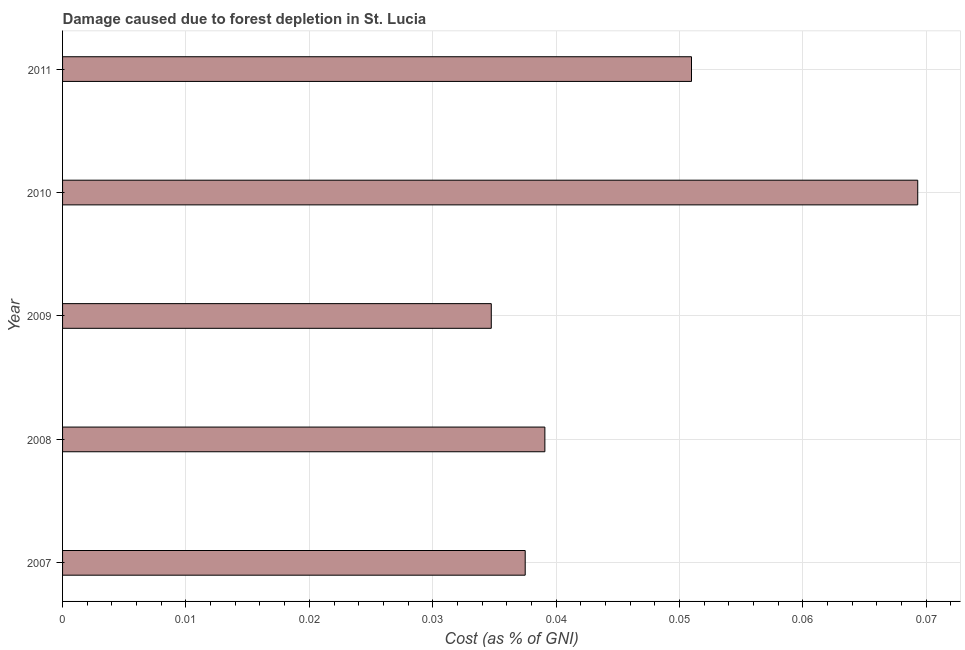What is the title of the graph?
Keep it short and to the point. Damage caused due to forest depletion in St. Lucia. What is the label or title of the X-axis?
Provide a short and direct response. Cost (as % of GNI). What is the label or title of the Y-axis?
Keep it short and to the point. Year. What is the damage caused due to forest depletion in 2007?
Your response must be concise. 0.04. Across all years, what is the maximum damage caused due to forest depletion?
Provide a short and direct response. 0.07. Across all years, what is the minimum damage caused due to forest depletion?
Make the answer very short. 0.03. In which year was the damage caused due to forest depletion minimum?
Your answer should be compact. 2009. What is the sum of the damage caused due to forest depletion?
Ensure brevity in your answer.  0.23. What is the difference between the damage caused due to forest depletion in 2008 and 2009?
Your response must be concise. 0. What is the average damage caused due to forest depletion per year?
Offer a terse response. 0.05. What is the median damage caused due to forest depletion?
Offer a terse response. 0.04. In how many years, is the damage caused due to forest depletion greater than 0.024 %?
Your answer should be compact. 5. Do a majority of the years between 2009 and 2007 (inclusive) have damage caused due to forest depletion greater than 0.036 %?
Give a very brief answer. Yes. What is the ratio of the damage caused due to forest depletion in 2008 to that in 2011?
Ensure brevity in your answer.  0.77. What is the difference between the highest and the second highest damage caused due to forest depletion?
Make the answer very short. 0.02. Is the sum of the damage caused due to forest depletion in 2009 and 2011 greater than the maximum damage caused due to forest depletion across all years?
Provide a succinct answer. Yes. What is the difference between the highest and the lowest damage caused due to forest depletion?
Offer a very short reply. 0.03. In how many years, is the damage caused due to forest depletion greater than the average damage caused due to forest depletion taken over all years?
Your answer should be compact. 2. How many bars are there?
Keep it short and to the point. 5. How many years are there in the graph?
Offer a very short reply. 5. What is the difference between two consecutive major ticks on the X-axis?
Your response must be concise. 0.01. Are the values on the major ticks of X-axis written in scientific E-notation?
Provide a short and direct response. No. What is the Cost (as % of GNI) of 2007?
Keep it short and to the point. 0.04. What is the Cost (as % of GNI) of 2008?
Provide a short and direct response. 0.04. What is the Cost (as % of GNI) of 2009?
Ensure brevity in your answer.  0.03. What is the Cost (as % of GNI) of 2010?
Give a very brief answer. 0.07. What is the Cost (as % of GNI) of 2011?
Give a very brief answer. 0.05. What is the difference between the Cost (as % of GNI) in 2007 and 2008?
Give a very brief answer. -0. What is the difference between the Cost (as % of GNI) in 2007 and 2009?
Provide a succinct answer. 0. What is the difference between the Cost (as % of GNI) in 2007 and 2010?
Offer a terse response. -0.03. What is the difference between the Cost (as % of GNI) in 2007 and 2011?
Your answer should be compact. -0.01. What is the difference between the Cost (as % of GNI) in 2008 and 2009?
Ensure brevity in your answer.  0. What is the difference between the Cost (as % of GNI) in 2008 and 2010?
Keep it short and to the point. -0.03. What is the difference between the Cost (as % of GNI) in 2008 and 2011?
Your answer should be very brief. -0.01. What is the difference between the Cost (as % of GNI) in 2009 and 2010?
Your answer should be very brief. -0.03. What is the difference between the Cost (as % of GNI) in 2009 and 2011?
Offer a very short reply. -0.02. What is the difference between the Cost (as % of GNI) in 2010 and 2011?
Provide a succinct answer. 0.02. What is the ratio of the Cost (as % of GNI) in 2007 to that in 2008?
Your response must be concise. 0.96. What is the ratio of the Cost (as % of GNI) in 2007 to that in 2009?
Keep it short and to the point. 1.08. What is the ratio of the Cost (as % of GNI) in 2007 to that in 2010?
Ensure brevity in your answer.  0.54. What is the ratio of the Cost (as % of GNI) in 2007 to that in 2011?
Give a very brief answer. 0.74. What is the ratio of the Cost (as % of GNI) in 2008 to that in 2010?
Offer a terse response. 0.56. What is the ratio of the Cost (as % of GNI) in 2008 to that in 2011?
Ensure brevity in your answer.  0.77. What is the ratio of the Cost (as % of GNI) in 2009 to that in 2010?
Offer a very short reply. 0.5. What is the ratio of the Cost (as % of GNI) in 2009 to that in 2011?
Offer a terse response. 0.68. What is the ratio of the Cost (as % of GNI) in 2010 to that in 2011?
Provide a short and direct response. 1.36. 